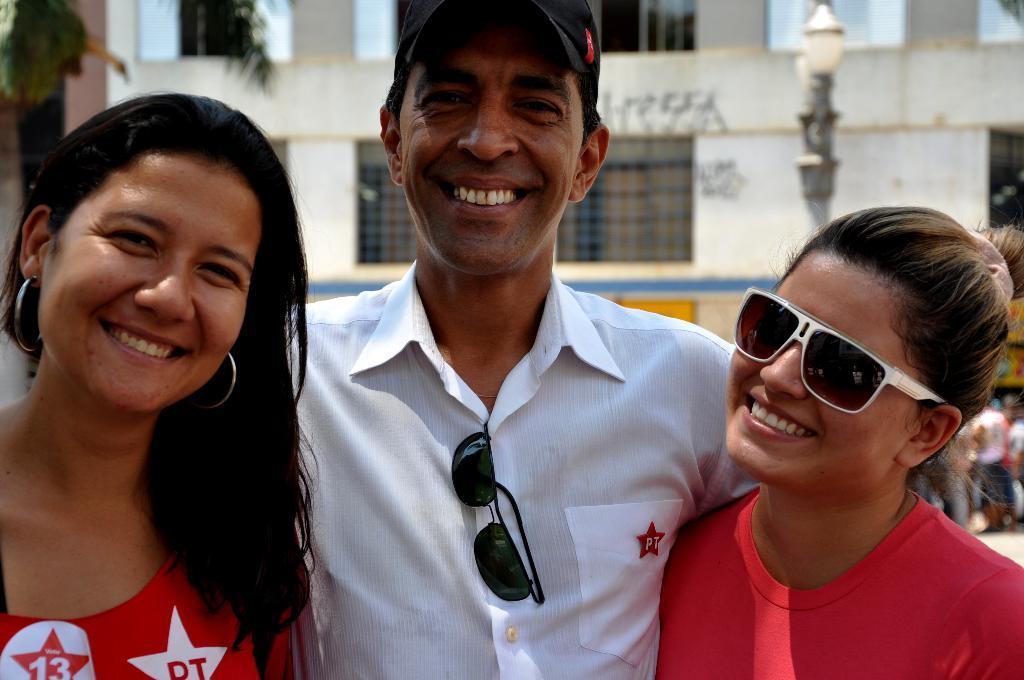Could you give a brief overview of what you see in this image? In this image we can see a man with two women and are smiling. In the background we can see a building and also light. 